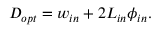<formula> <loc_0><loc_0><loc_500><loc_500>D _ { o p t } = w _ { i n } + 2 L _ { i n } \phi _ { i n } .</formula> 